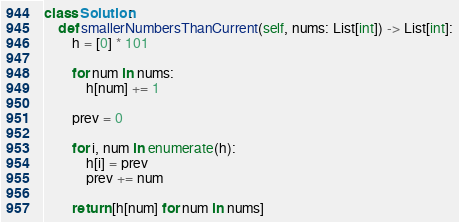Convert code to text. <code><loc_0><loc_0><loc_500><loc_500><_Python_>class Solution:
    def smallerNumbersThanCurrent(self, nums: List[int]) -> List[int]:
        h = [0] * 101

        for num in nums:
            h[num] += 1

        prev = 0

        for i, num in enumerate(h):
            h[i] = prev
            prev += num

        return [h[num] for num in nums]</code> 